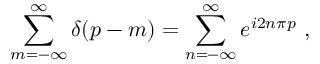Convert formula to latex. <formula><loc_0><loc_0><loc_500><loc_500>\sum _ { m = - \infty } ^ { \infty } \delta \, \left ( p - m \right ) = \sum _ { n = - \infty } ^ { \infty } e ^ { i 2 n \pi p } \ ,</formula> 